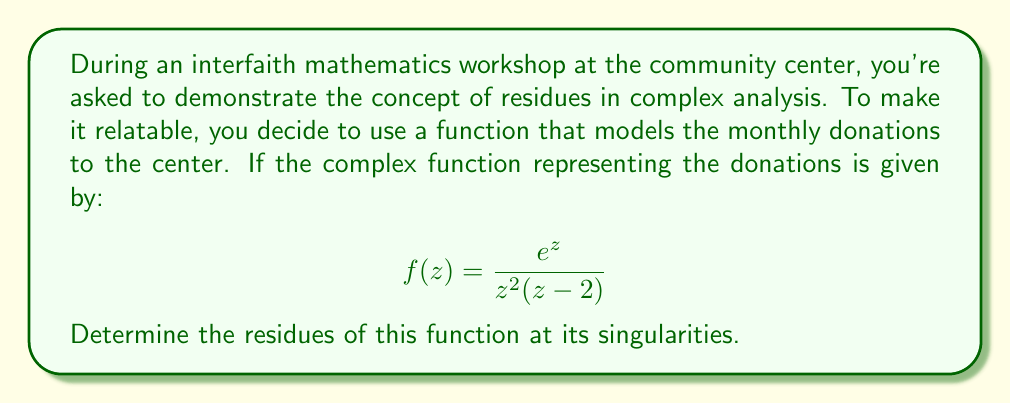Can you answer this question? Let's approach this step-by-step:

1) First, we need to identify the singularities of the function. They occur when the denominator is zero:
   
   $z^2(z-2) = 0$
   
   This gives us $z = 0$ (double root) and $z = 2$

2) For $z = 0$ (double pole):
   We use the formula for the residue at a double pole:
   
   $$\text{Res}(f,0) = \lim_{z \to 0} \frac{d}{dz}\left[z^2 f(z)\right]$$
   
   $$= \lim_{z \to 0} \frac{d}{dz}\left[\frac{z^2e^z}{z^2(z-2)}\right] = \lim_{z \to 0} \frac{d}{dz}\left[\frac{e^z}{z-2}\right]$$
   
   $$= \lim_{z \to 0} \frac{e^z(z-2) - e^z}{(z-2)^2} = \frac{e^0 \cdot (-2) - e^0}{(-2)^2} = \frac{-1-1}{4} = -\frac{1}{2}$$

3) For $z = 2$ (simple pole):
   We use the formula for the residue at a simple pole:
   
   $$\text{Res}(f,2) = \lim_{z \to 2} (z-2)f(z) = \lim_{z \to 2} \frac{(z-2)e^z}{z^2(z-2)} = \lim_{z \to 2} \frac{e^z}{z^2} = \frac{e^2}{4}$$

Thus, we have found the residues at all singularities of the function.
Answer: The residues are:

At $z = 0$: $\text{Res}(f,0) = -\frac{1}{2}$

At $z = 2$: $\text{Res}(f,2) = \frac{e^2}{4}$ 